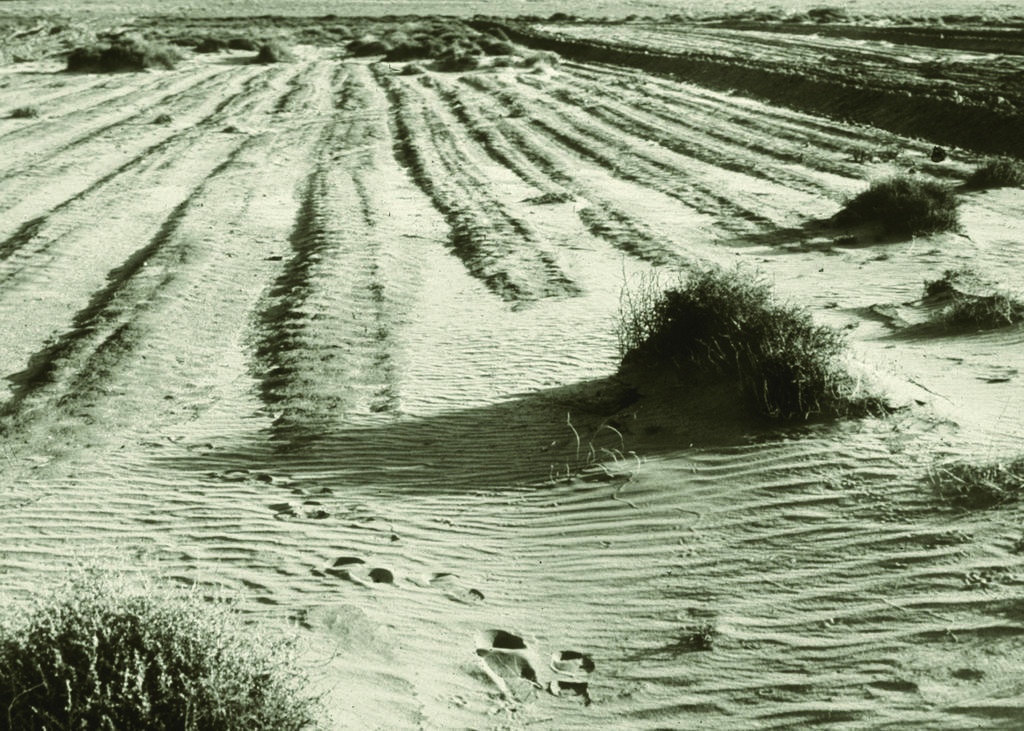Could you give a brief overview of what you see in this image? In this image, we can see some plants on the ground. 